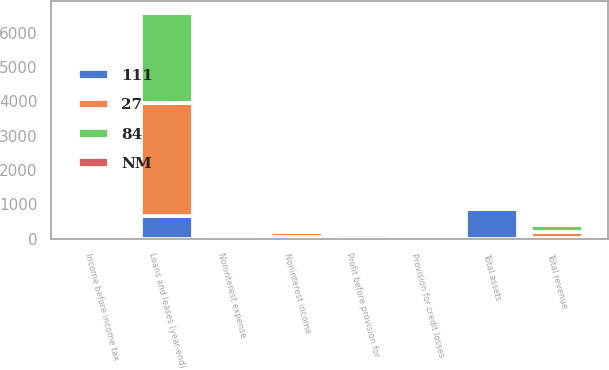<chart> <loc_0><loc_0><loc_500><loc_500><stacked_bar_chart><ecel><fcel>Noninterest income<fcel>Total revenue<fcel>Noninterest expense<fcel>Profit before provision for<fcel>Provision for credit losses<fcel>Income before income tax<fcel>Loans and leases (year-end)<fcel>Total assets<nl><fcel>84<fcel>91<fcel>202<fcel>109<fcel>93<fcel>37<fcel>56<fcel>2616<fcel>60.5<nl><fcel>27<fcel>148<fcel>175<fcel>64<fcel>111<fcel>79<fcel>32<fcel>3282<fcel>60.5<nl><fcel>111<fcel>57<fcel>27<fcel>45<fcel>18<fcel>42<fcel>24<fcel>666<fcel>856<nl><fcel>NM<fcel>39<fcel>15<fcel>70<fcel>16<fcel>53<fcel>75<fcel>20<fcel>2<nl></chart> 